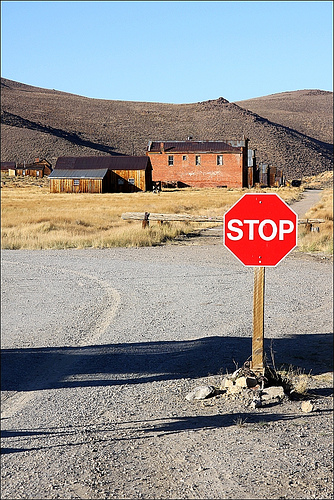Read all the text in this image. STOP 